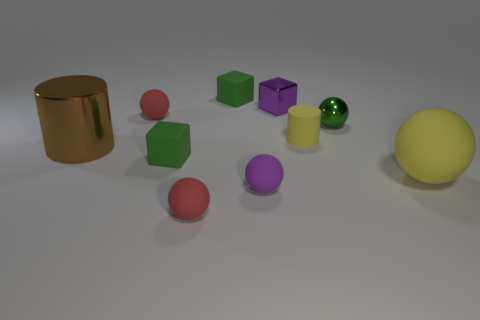Subtract all tiny shiny spheres. How many spheres are left? 4 Subtract all yellow balls. How many balls are left? 4 Subtract all cyan spheres. Subtract all blue cylinders. How many spheres are left? 5 Subtract all cubes. How many objects are left? 7 Subtract all large purple metallic cubes. Subtract all large brown metal things. How many objects are left? 9 Add 6 tiny green objects. How many tiny green objects are left? 9 Add 4 tiny metallic blocks. How many tiny metallic blocks exist? 5 Subtract 0 yellow blocks. How many objects are left? 10 